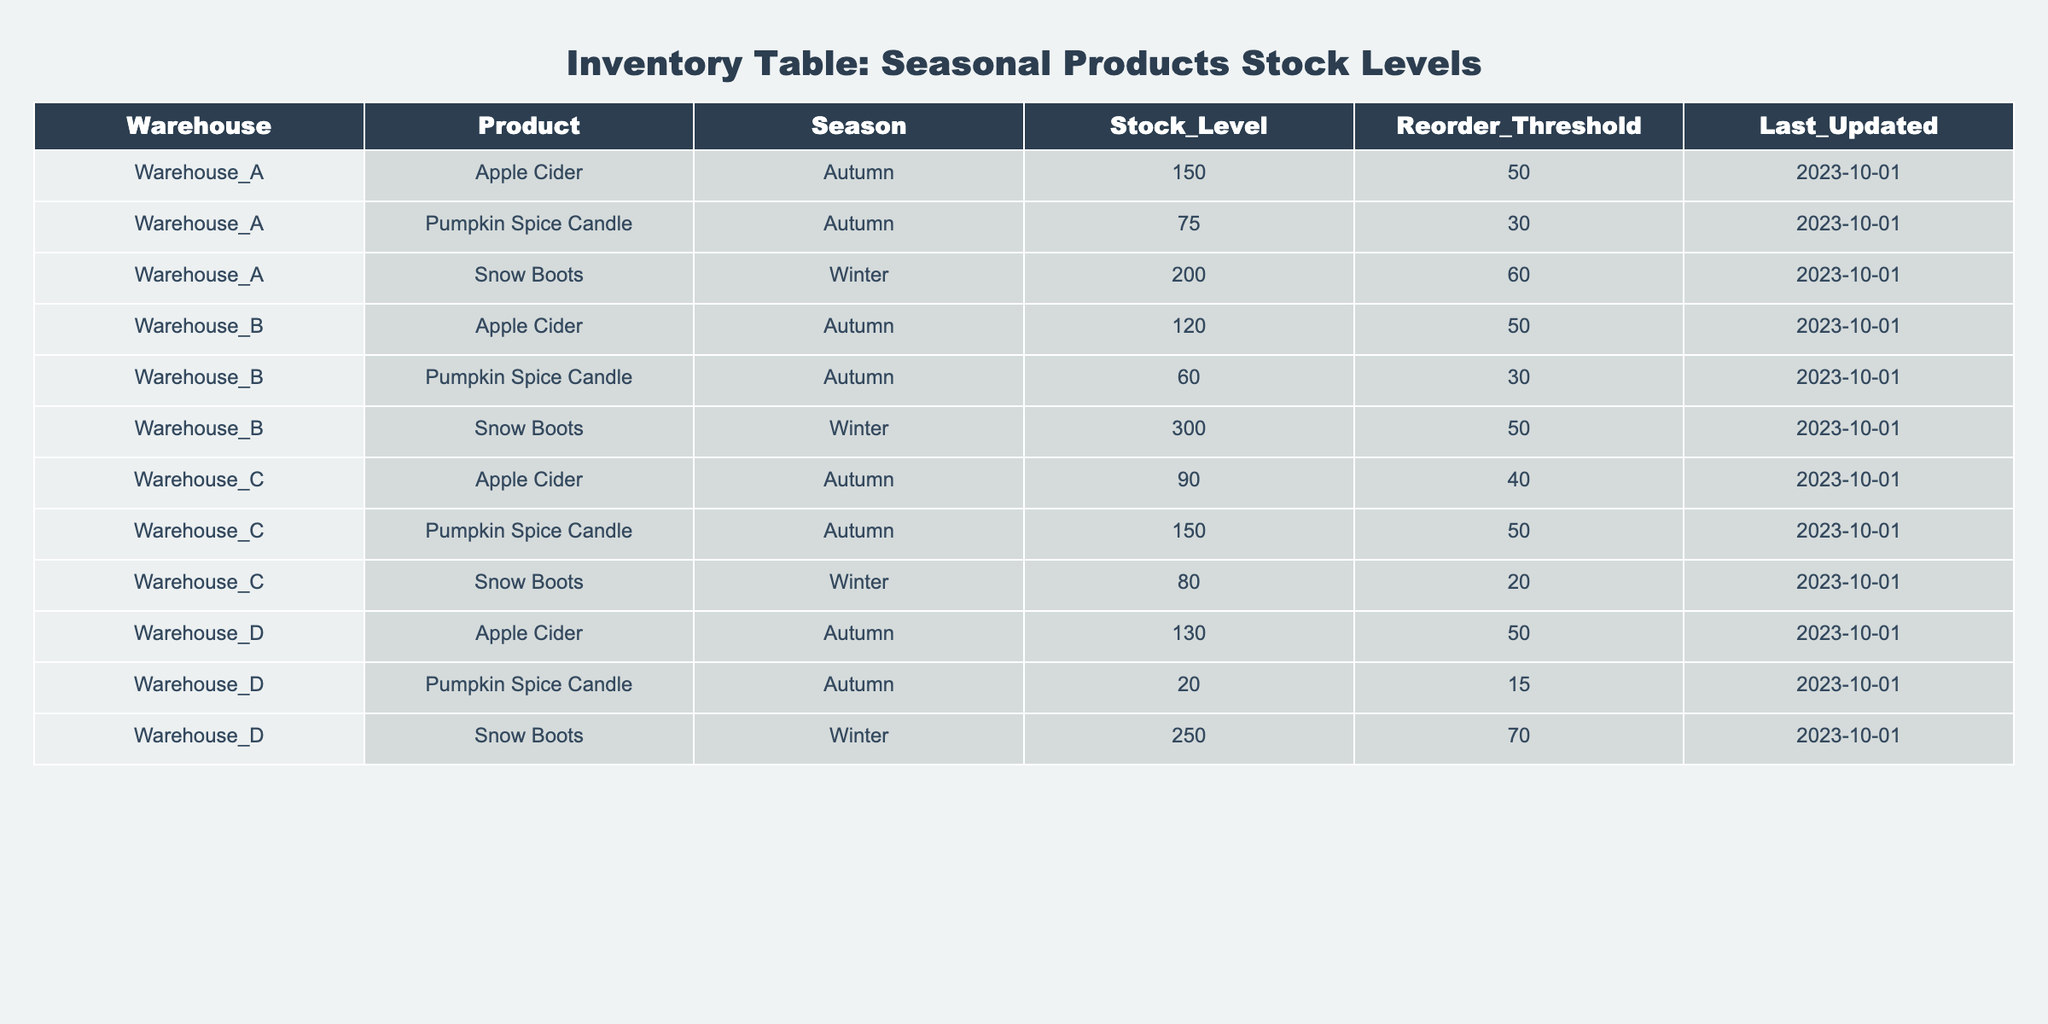What is the stock level of Snow Boots in Warehouse B? The table shows that in Warehouse B, the stock level for Snow Boots is listed directly. By looking at the row for Warehouse B and Snow Boots, the stock level is 300.
Answer: 300 Which product has the highest stock level in Warehouse D? In Warehouse D, there are three products listed: Apple Cider (130), Pumpkin Spice Candle (20), and Snow Boots (250). Comparing these values, Snow Boots has the highest stock level at 250.
Answer: Snow Boots What is the total stock level of Apple Cider across all warehouses? The stock levels of Apple Cider are as follows: Warehouse A - 150, Warehouse B - 120, Warehouse C - 90, and Warehouse D - 130. Summing these values gives 150 + 120 + 90 + 130 = 490.
Answer: 490 Is the stock level of Pumpkin Spice Candle in Warehouse C greater than the reorder threshold? In Warehouse C, the stock level of Pumpkin Spice Candle is 150, and the reorder threshold is 50. Since 150 is greater than 50, the answer is yes.
Answer: Yes Which warehouse has the lowest stock level for Snow Boots, and what is that stock level? The stock levels for Snow Boots are: Warehouse A - 200, Warehouse B - 300, Warehouse C - 80, and Warehouse D - 250. The lowest level is in Warehouse C at 80.
Answer: Warehouse C, 80 How many products have stock levels below their reorder thresholds in total? Checking each product against its reorder threshold: Warehouse A has Pumpkin Spice Candle (75 < 30), Warehouse B has Pumpkin Spice Candle (60 < 30) and Warehouse A's Apple Cider is above threshold. Warehouse C's Snow Boots (80 < 20) and Warehouse D's Pumpkin Spice Candle (20 < 15). The total is 3 products.
Answer: 3 What is the average stock level of products in Warehouse A? The stock levels in Warehouse A are: Apple Cider (150), Pumpkin Spice Candle (75), and Snow Boots (200). The average is calculated as (150 + 75 + 200) / 3 = 141.67.
Answer: 141.67 Is the last updated date for Inventory the same for all warehouses? The last updated date for all rows is 2023-10-01. Since all entries share the same date, the answer is yes.
Answer: Yes How does the stock level of Pumpkin Spice Candle in Warehouse D compare to all other warehouses? The stock levels of Pumpkin Spice Candle are: Warehouse A (75), Warehouse B (60), Warehouse C (150), and Warehouse D (20). Warehouse D has the lowest level at 20.
Answer: Warehouse D is the lowest 